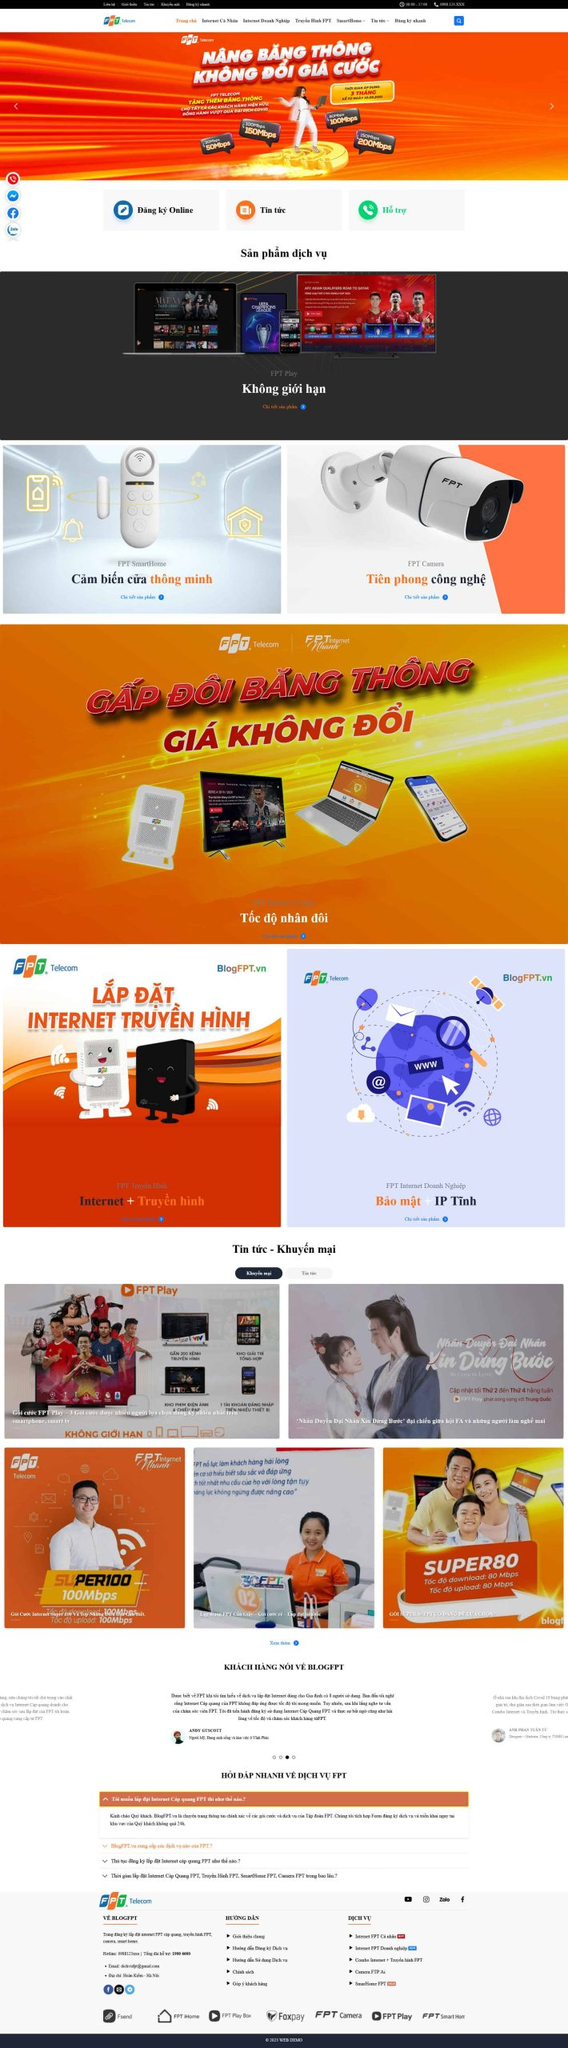Liệt kê 5 ngành nghề, lĩnh vực phù hợp với website này, phân cách các màu sắc bằng dấu phẩy. Chỉ trả về kết quả, phân cách bằng dấy phẩy
 Viễn thông, Công nghệ thông tin, Truyền hình, Bảo mật, Thiết bị thông minh 